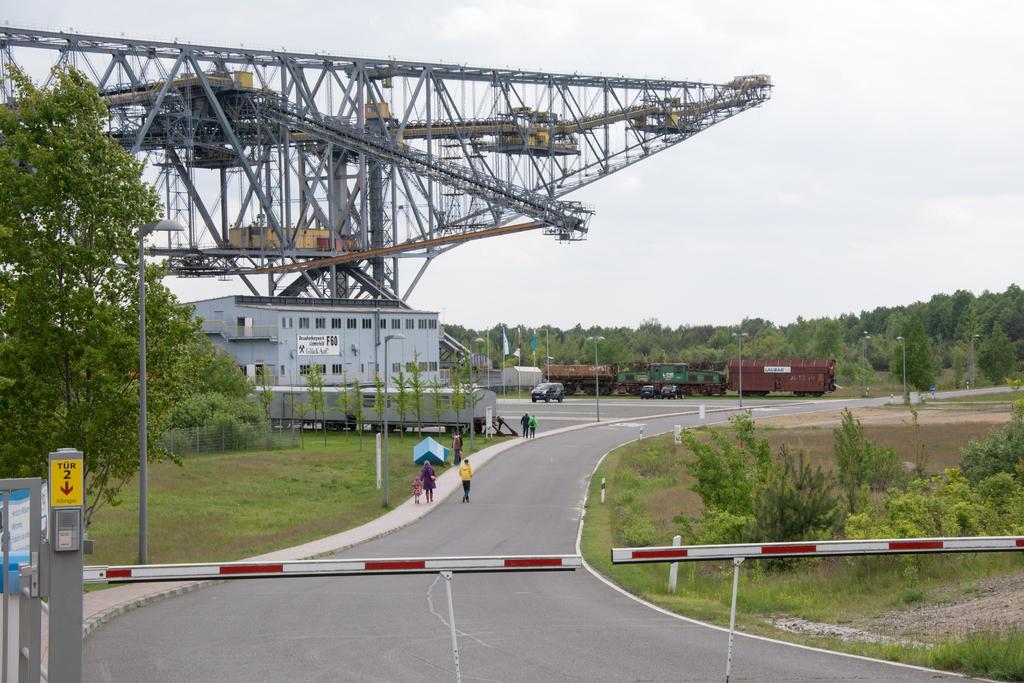Could you give a brief overview of what you see in this image? In this image a person is walking on the road. Few people are walking on the pavement. Bottom of the image there is a metal rod attached to the pole. There are vehicles on the road. Behind there is a train. Right side there are plants and trees on the grassland. Left side there is a fence on the grassland. Behind there is a building. Behind there is a construction. Few flags are attached to the poles. Background there are trees. Top of the image there is sky. Street lights are on the grassland. 